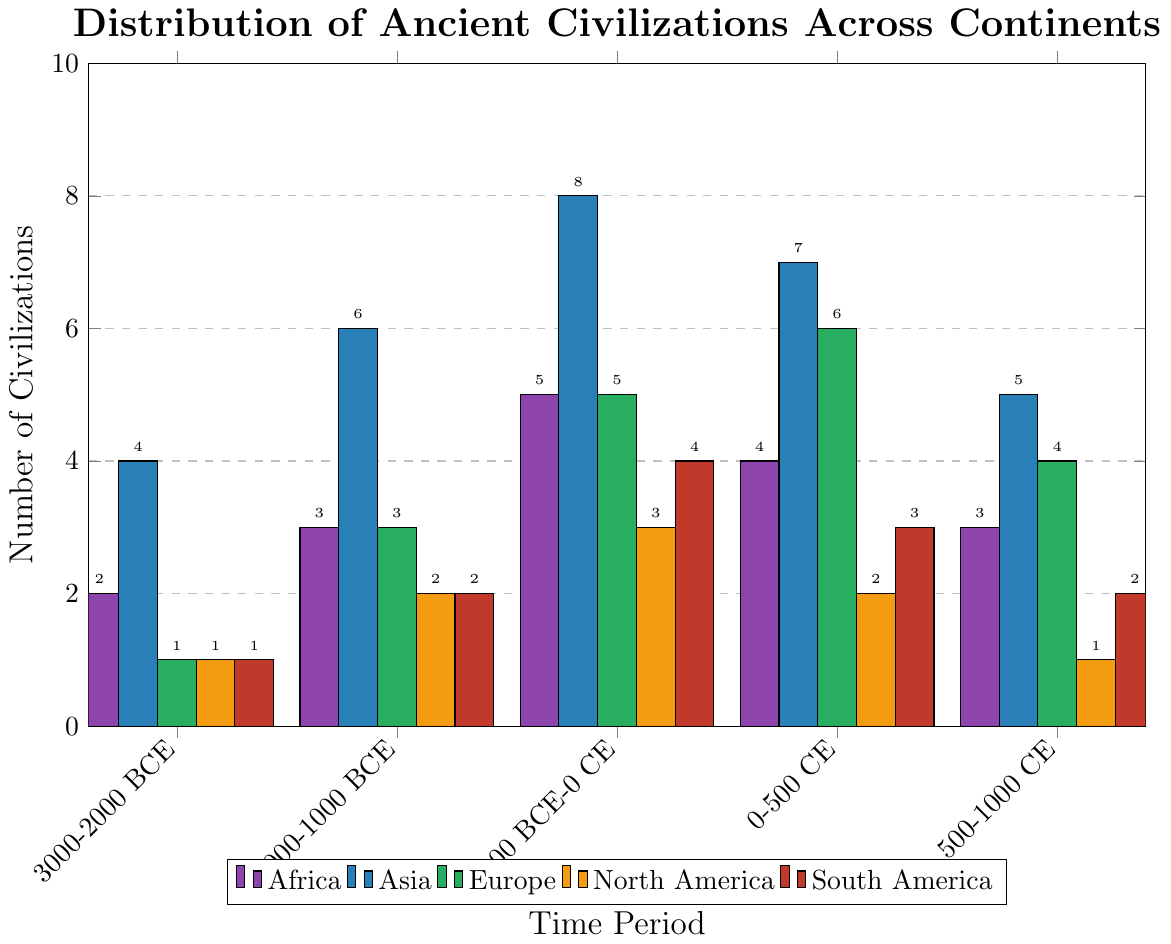Which continent has the most ancient civilizations in the period 2000-1000 BCE? By observing the height of the bars in the 2000-1000 BCE period, the bar representing Asia is the tallest, indicating that it has the highest number of civilizations.
Answer: Asia How many total civilizations are represented across all continents in the period 0-500 CE? Sum the number of civilizations for each continent in the 0-500 CE period: Africa (4) + Asia (7) + Europe (6) + North America (2) + South America (3) = 22.
Answer: 22 Which period shows the highest number of civilizations for Europe? Look at the height of the bars for Europe in each period; the tallest bar is in the period 0-500 CE.
Answer: 0-500 CE How does the number of civilizations in Africa in the 3000-2000 BCE period compare to those in North America in the same period? Compare the heights of the bars for Africa and North America in the 3000-2000 BCE period; both bars are equal in height.
Answer: Equal Between Asia and South America, which continent experienced a greater increase in the number of civilizations from 3000-2000 BCE to 1000 BCE-0 CE? Calculate the change for each:
Asia: 8 (1000 BCE-0 CE) - 4 (3000-2000 BCE) = +4
South America: 4 (1000 BCE-0 CE) - 1 (3000-2000 BCE) = +3
Asia had a greater increase.
Answer: Asia What is the average number of civilizations across all continents in the period 500-1000 CE? Compute the average: (3 + 5 + 4 + 1 + 2 + 1) / 6 = 16 / 6 ≈ 2.67.
Answer: 2.67 Compare the number of civilizations in Asia and Europe in the period 2000-1000 BCE; which is higher and by how much? Asia has 6 civilizations, and Europe has 3, so Asia has 6 - 3 = 3 more civilizations.
Answer: Asia by 3 Which continent consistently shows a low number of civilizations across all listed periods? By observing the bars for all periods, Oceania consistently shows a low number of civilizations (0 or 1).
Answer: Oceania What is the difference between the highest and lowest number of civilizations in the 1000 BCE-0 CE period across all continents? The highest is Asia (8), and the lowest is Oceania (1). The difference is 8 - 1 = 7.
Answer: 7 How many civilizations are shared between Europe and South America in the period 1000 BCE-0 CE? In the 1000 BCE-0 CE period: Europe has 5 and South America has 4. The combined total is 5 + 4 = 9.
Answer: 9 